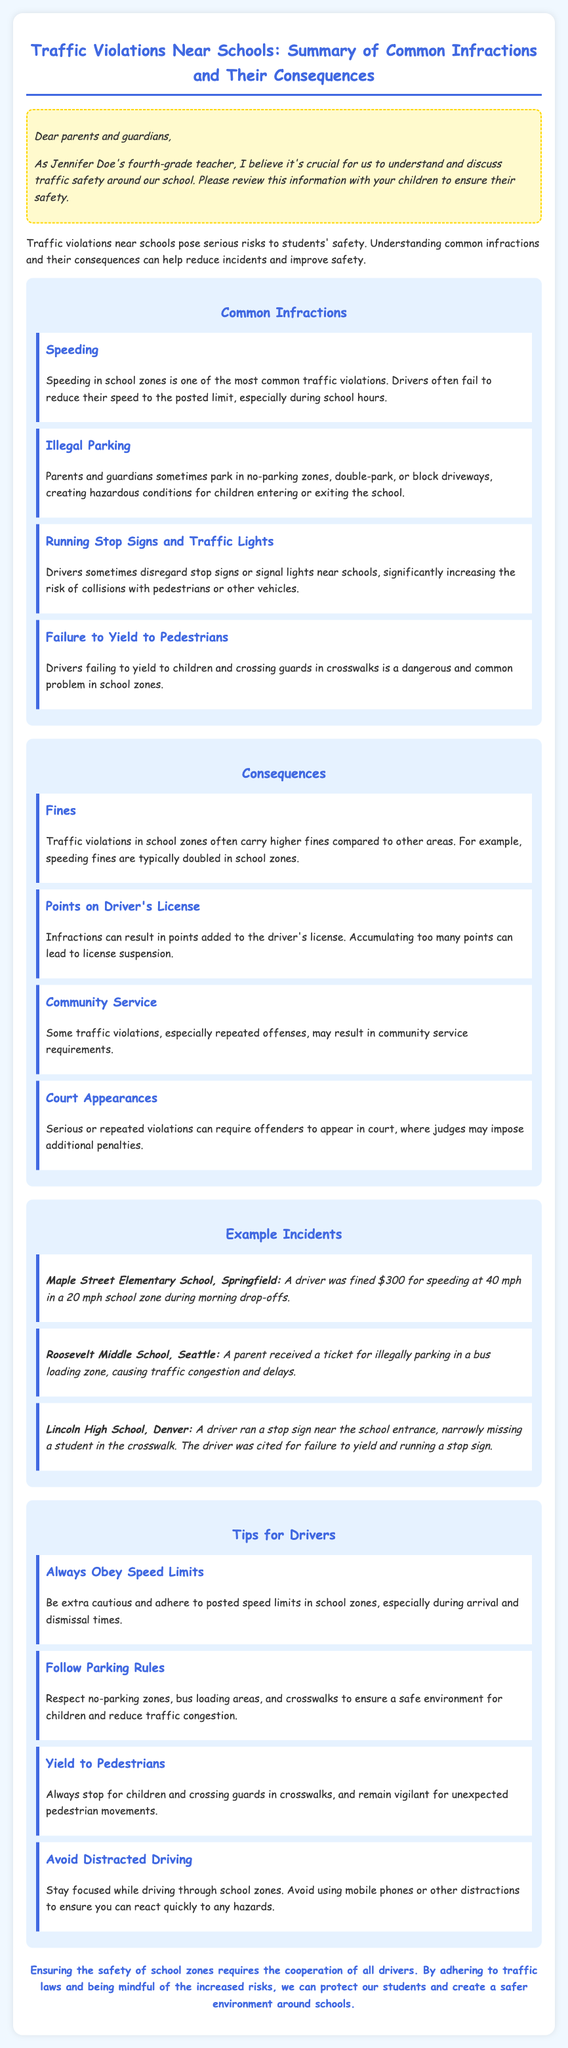What is the document about? The document provides a summary of common traffic violations near schools along with their consequences and safety tips for drivers.
Answer: Traffic Violations Near Schools What is one common infraction mentioned? The document lists several common infractions, asking for any of them.
Answer: Speeding What is the consequence for violating traffic rules in school zones? The document states various consequences for infractions, asking for one of them.
Answer: Fines How much was the fine for speeding at Maple Street Elementary School? The document provides specific incident details, including the fine amount for speeding.
Answer: $300 What should drivers do to ensure safety in school zones? The document offers multiple tips for drivers, asking for one of them.
Answer: Yield to Pedestrians Which school had a parent ticketed for illegal parking? The document gives examples of incidents related to traffic violations near schools.
Answer: Roosevelt Middle School How many tips are provided for drivers? The document outlines specific safety tips for drivers, requesting the total number.
Answer: Four What penalty can result from accumulating too many points on a driver's license? The document mentions consequences associated with points on a license.
Answer: License suspension What color is the background of the document? The document's style includes specific colors and formatting.
Answer: Light blue 